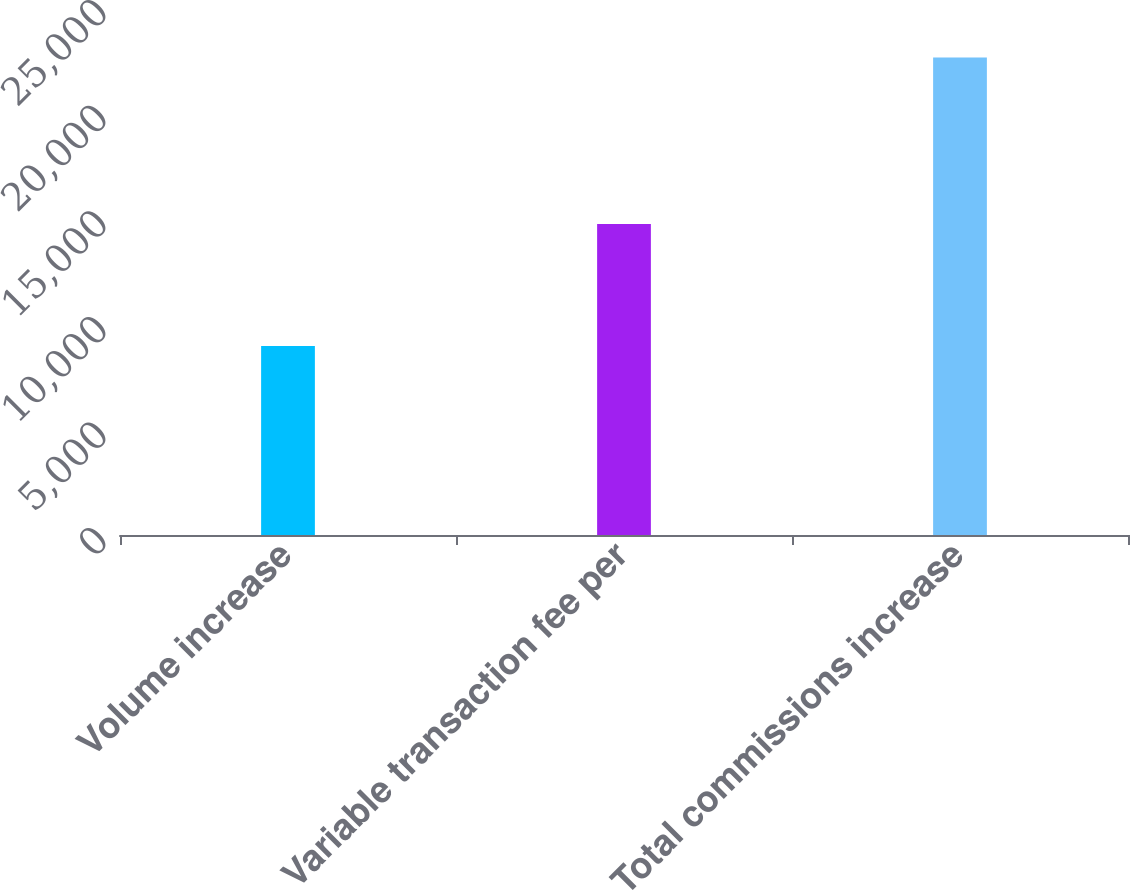Convert chart. <chart><loc_0><loc_0><loc_500><loc_500><bar_chart><fcel>Volume increase<fcel>Variable transaction fee per<fcel>Total commissions increase<nl><fcel>8950<fcel>14727<fcel>22604<nl></chart> 